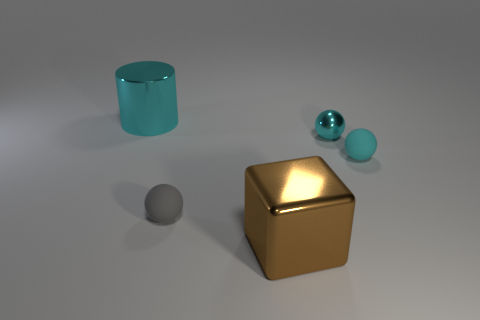Is the large metallic cylinder the same color as the metal ball?
Offer a terse response. Yes. Are there fewer matte things that are to the left of the cube than small things?
Give a very brief answer. Yes. How many small things are there?
Provide a succinct answer. 3. There is a cyan metal object that is to the right of the cyan metallic object behind the small cyan metal thing; what shape is it?
Ensure brevity in your answer.  Sphere. There is a tiny gray sphere; how many matte things are right of it?
Provide a short and direct response. 1. Are the brown thing and the big thing behind the metal sphere made of the same material?
Offer a terse response. Yes. Are there any blue metal cubes of the same size as the cyan rubber thing?
Ensure brevity in your answer.  No. Are there the same number of big metallic cylinders on the right side of the tiny cyan matte ball and tiny blue shiny blocks?
Your answer should be very brief. Yes. How big is the gray ball?
Keep it short and to the point. Small. There is a small cyan object right of the small metal sphere; what number of spheres are behind it?
Provide a short and direct response. 1. 